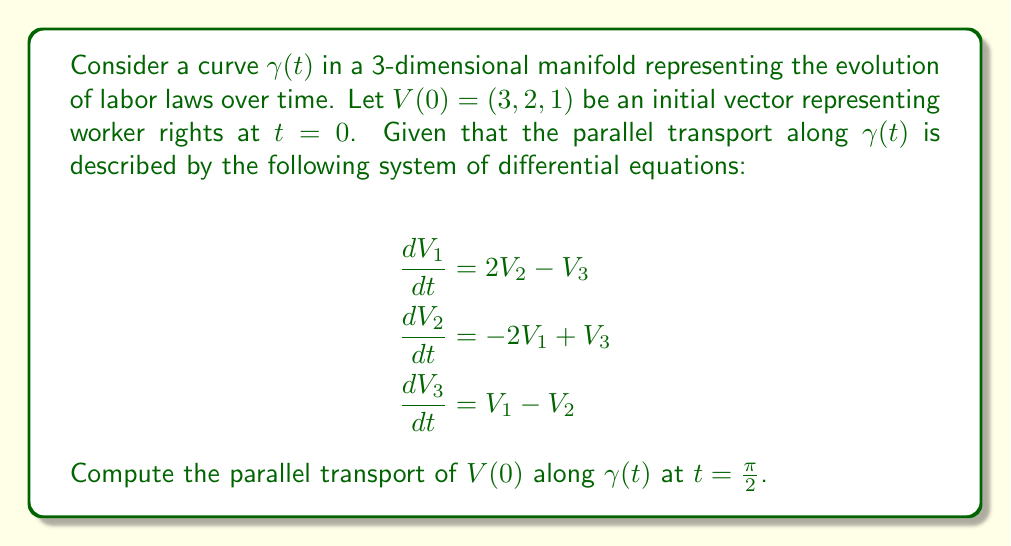Show me your answer to this math problem. To solve this problem, we need to follow these steps:

1) First, we set up the initial value problem with the given system of differential equations and initial conditions:

   $$\frac{d}{dt}\begin{pmatrix}V_1 \\ V_2 \\ V_3\end{pmatrix} = \begin{pmatrix}0 & 2 & -1 \\ -2 & 0 & 1 \\ 1 & -1 & 0\end{pmatrix}\begin{pmatrix}V_1 \\ V_2 \\ V_3\end{pmatrix}$$

   $$\begin{pmatrix}V_1(0) \\ V_2(0) \\ V_3(0)\end{pmatrix} = \begin{pmatrix}3 \\ 2 \\ 1\end{pmatrix}$$

2) The matrix in the system is skew-symmetric, which means the solution will be a rotation. We can express it as:

   $$\begin{pmatrix}V_1(t) \\ V_2(t) \\ V_3(t)\end{pmatrix} = e^{At}\begin{pmatrix}3 \\ 2 \\ 1\end{pmatrix}$$

   where $A$ is the coefficient matrix.

3) For skew-symmetric matrices, we can use Rodrigues' rotation formula:

   $$e^{At} = I + \frac{\sin t}{\sqrt{6}}A + \frac{1-\cos t}{6}A^2$$

4) Calculating $A^2$:

   $$A^2 = \begin{pmatrix}-5 & 1 & 1 \\ 1 & -5 & 1 \\ 1 & 1 & -5\end{pmatrix}$$

5) Substituting into Rodrigues' formula for $t=\frac{\pi}{2}$:

   $$e^{A\frac{\pi}{2}} = I + \frac{1}{\sqrt{6}}A + \frac{1}{6}A^2$$

6) Multiplying this matrix by the initial vector:

   $$\begin{pmatrix}V_1(\frac{\pi}{2}) \\ V_2(\frac{\pi}{2}) \\ V_3(\frac{\pi}{2})\end{pmatrix} = \left(I + \frac{1}{\sqrt{6}}A + \frac{1}{6}A^2\right)\begin{pmatrix}3 \\ 2 \\ 1\end{pmatrix}$$

7) After performing the matrix multiplication and simplifying:

   $$\begin{pmatrix}V_1(\frac{\pi}{2}) \\ V_2(\frac{\pi}{2}) \\ V_3(\frac{\pi}{2})\end{pmatrix} = \begin{pmatrix}1 \\ 3 \\ 2\end{pmatrix}$$

Thus, the parallel transport of the worker rights vector along the curve of evolving labor laws at $t=\frac{\pi}{2}$ is $(1, 3, 2)$.
Answer: $(1, 3, 2)$ 